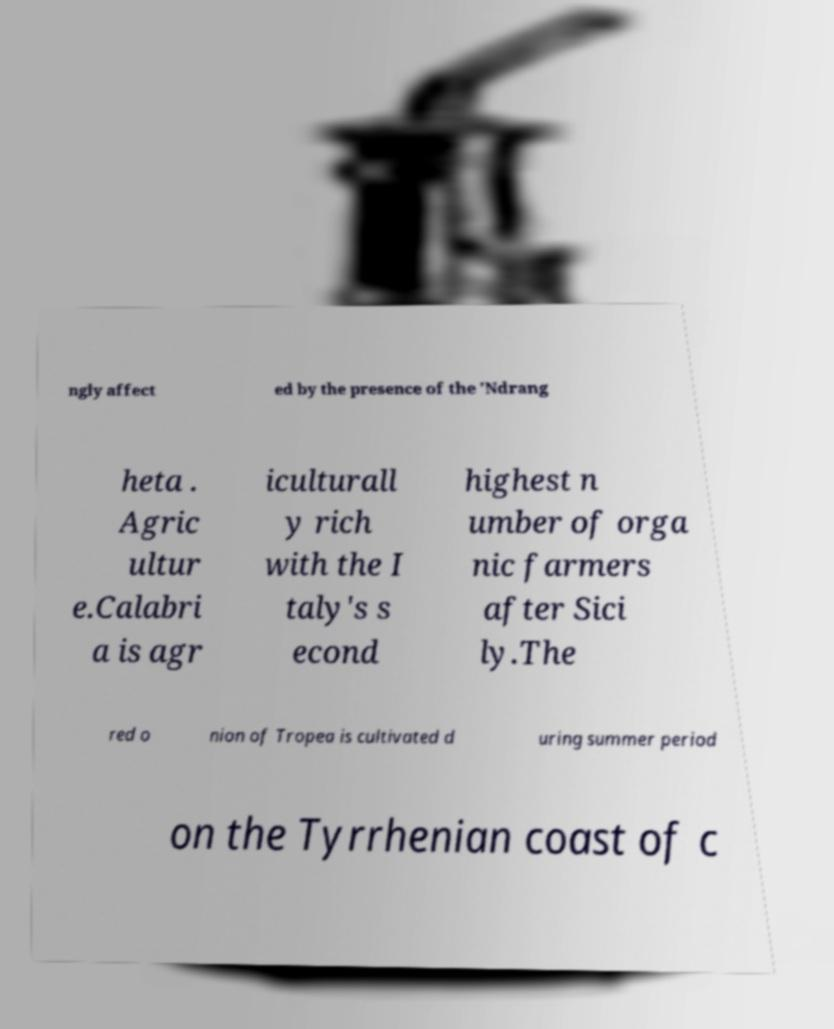What messages or text are displayed in this image? I need them in a readable, typed format. ngly affect ed by the presence of the 'Ndrang heta . Agric ultur e.Calabri a is agr iculturall y rich with the I taly's s econd highest n umber of orga nic farmers after Sici ly.The red o nion of Tropea is cultivated d uring summer period on the Tyrrhenian coast of c 